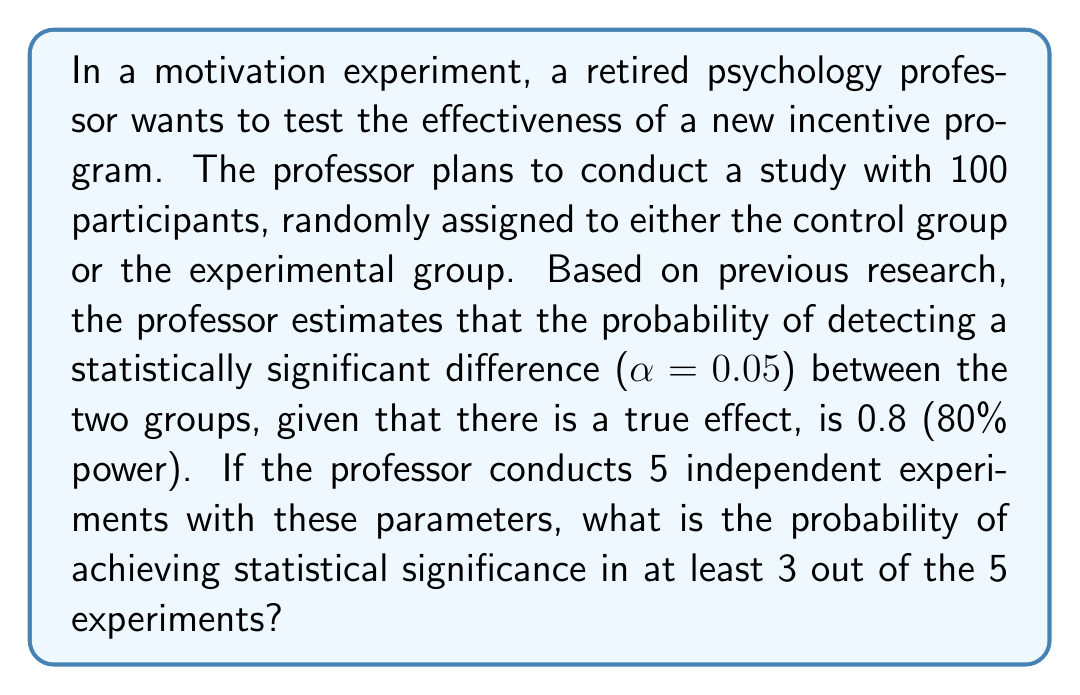Show me your answer to this math problem. To solve this problem, we'll use the binomial probability distribution.

Step 1: Identify the parameters
- Number of trials (experiments): n = 5
- Probability of success (achieving statistical significance) in each trial: p = 0.8
- Number of successes we're interested in: k ≥ 3

Step 2: Calculate the probability of exactly 3, 4, and 5 successes
We'll use the binomial probability formula:
$$ P(X = k) = \binom{n}{k} p^k (1-p)^{n-k} $$

For k = 3:
$$ P(X = 3) = \binom{5}{3} (0.8)^3 (0.2)^2 = 10 \times 0.512 \times 0.04 = 0.2048 $$

For k = 4:
$$ P(X = 4) = \binom{5}{4} (0.8)^4 (0.2)^1 = 5 \times 0.4096 \times 0.2 = 0.4096 $$

For k = 5:
$$ P(X = 5) = \binom{5}{5} (0.8)^5 (0.2)^0 = 1 \times 0.32768 \times 1 = 0.32768 $$

Step 3: Sum the probabilities for 3, 4, and 5 successes
$$ P(X \geq 3) = P(X = 3) + P(X = 4) + P(X = 5) $$
$$ P(X \geq 3) = 0.2048 + 0.4096 + 0.32768 = 0.94208 $$

Therefore, the probability of achieving statistical significance in at least 3 out of 5 experiments is approximately 0.94208 or 94.21%.
Answer: 0.94208 